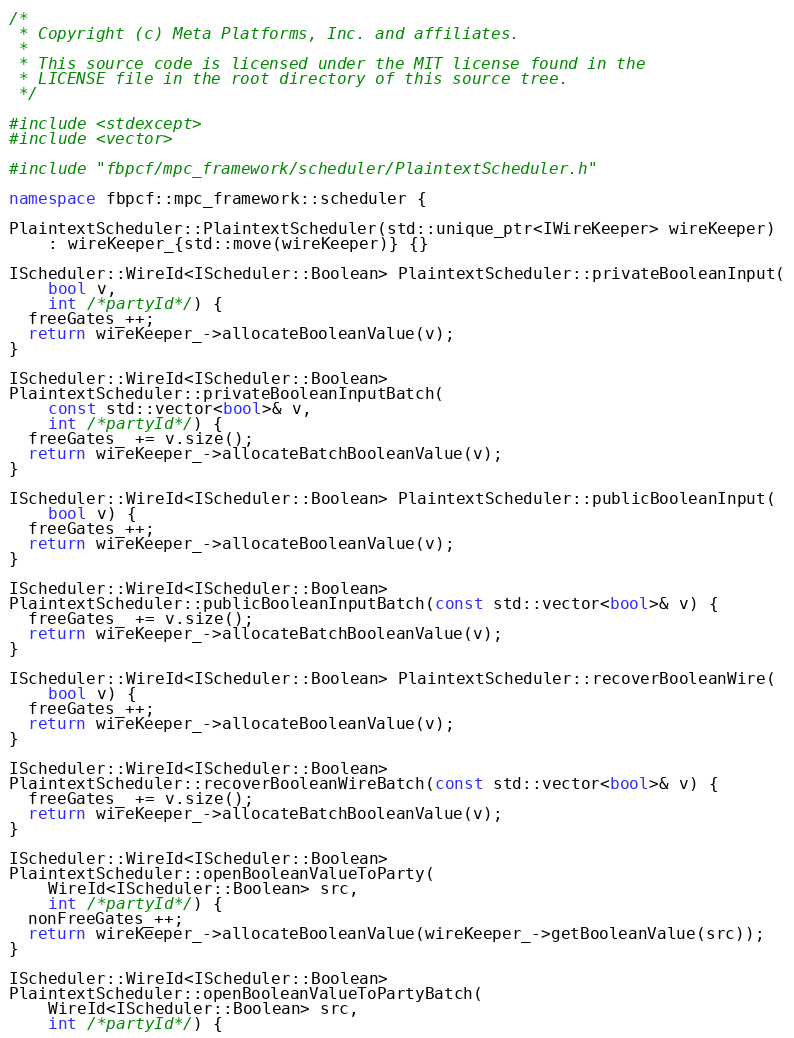Convert code to text. <code><loc_0><loc_0><loc_500><loc_500><_C++_>/*
 * Copyright (c) Meta Platforms, Inc. and affiliates.
 *
 * This source code is licensed under the MIT license found in the
 * LICENSE file in the root directory of this source tree.
 */

#include <stdexcept>
#include <vector>

#include "fbpcf/mpc_framework/scheduler/PlaintextScheduler.h"

namespace fbpcf::mpc_framework::scheduler {

PlaintextScheduler::PlaintextScheduler(std::unique_ptr<IWireKeeper> wireKeeper)
    : wireKeeper_{std::move(wireKeeper)} {}

IScheduler::WireId<IScheduler::Boolean> PlaintextScheduler::privateBooleanInput(
    bool v,
    int /*partyId*/) {
  freeGates_++;
  return wireKeeper_->allocateBooleanValue(v);
}

IScheduler::WireId<IScheduler::Boolean>
PlaintextScheduler::privateBooleanInputBatch(
    const std::vector<bool>& v,
    int /*partyId*/) {
  freeGates_ += v.size();
  return wireKeeper_->allocateBatchBooleanValue(v);
}

IScheduler::WireId<IScheduler::Boolean> PlaintextScheduler::publicBooleanInput(
    bool v) {
  freeGates_++;
  return wireKeeper_->allocateBooleanValue(v);
}

IScheduler::WireId<IScheduler::Boolean>
PlaintextScheduler::publicBooleanInputBatch(const std::vector<bool>& v) {
  freeGates_ += v.size();
  return wireKeeper_->allocateBatchBooleanValue(v);
}

IScheduler::WireId<IScheduler::Boolean> PlaintextScheduler::recoverBooleanWire(
    bool v) {
  freeGates_++;
  return wireKeeper_->allocateBooleanValue(v);
}

IScheduler::WireId<IScheduler::Boolean>
PlaintextScheduler::recoverBooleanWireBatch(const std::vector<bool>& v) {
  freeGates_ += v.size();
  return wireKeeper_->allocateBatchBooleanValue(v);
}

IScheduler::WireId<IScheduler::Boolean>
PlaintextScheduler::openBooleanValueToParty(
    WireId<IScheduler::Boolean> src,
    int /*partyId*/) {
  nonFreeGates_++;
  return wireKeeper_->allocateBooleanValue(wireKeeper_->getBooleanValue(src));
}

IScheduler::WireId<IScheduler::Boolean>
PlaintextScheduler::openBooleanValueToPartyBatch(
    WireId<IScheduler::Boolean> src,
    int /*partyId*/) {</code> 